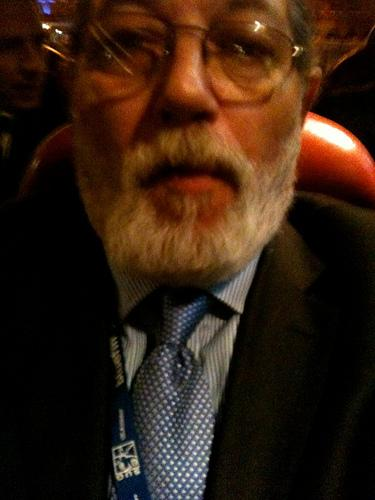The person wearing the blue tie looks most like whom? old man 